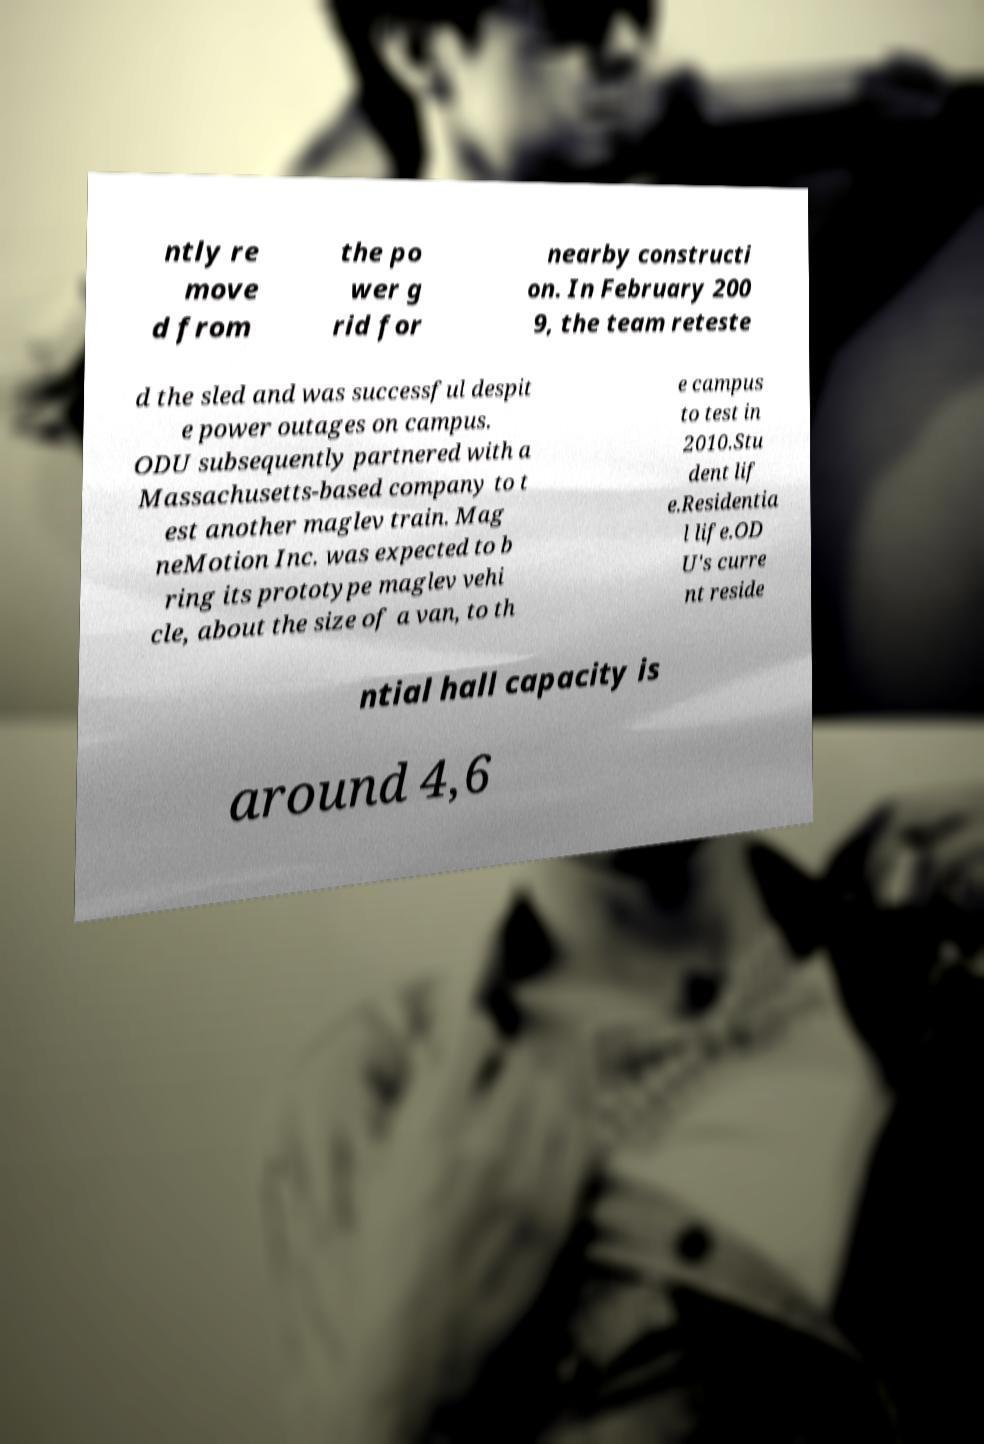Can you accurately transcribe the text from the provided image for me? ntly re move d from the po wer g rid for nearby constructi on. In February 200 9, the team reteste d the sled and was successful despit e power outages on campus. ODU subsequently partnered with a Massachusetts-based company to t est another maglev train. Mag neMotion Inc. was expected to b ring its prototype maglev vehi cle, about the size of a van, to th e campus to test in 2010.Stu dent lif e.Residentia l life.OD U's curre nt reside ntial hall capacity is around 4,6 